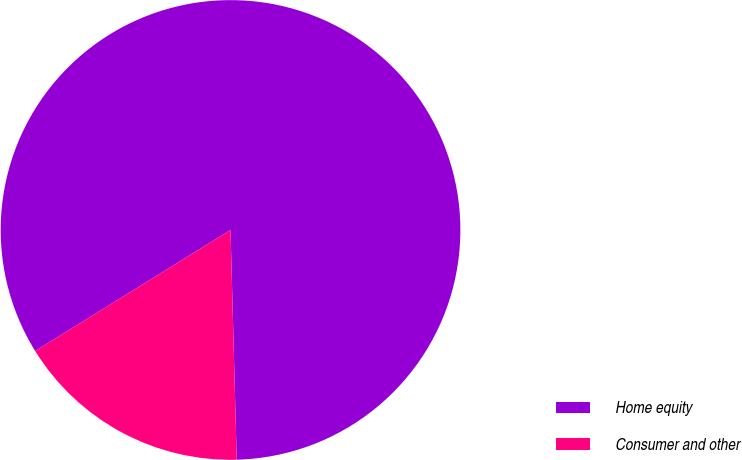Convert chart. <chart><loc_0><loc_0><loc_500><loc_500><pie_chart><fcel>Home equity<fcel>Consumer and other<nl><fcel>83.4%<fcel>16.6%<nl></chart> 